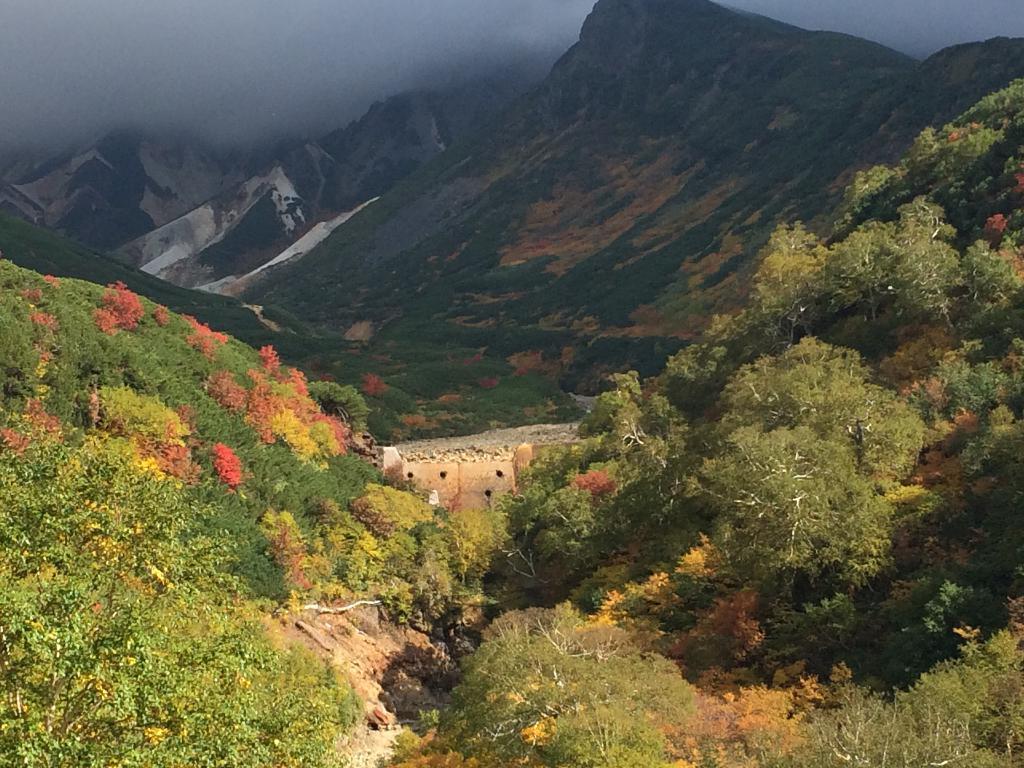Could you give a brief overview of what you see in this image? In the image we can see the ground is covered with grass and there are plants and there are lot of trees. Behind there are mountains. 